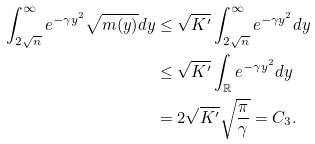<formula> <loc_0><loc_0><loc_500><loc_500>\int _ { 2 \sqrt { n } } ^ { \infty } e ^ { - \gamma y ^ { 2 } } \sqrt { m ( y ) } d y & \leq \sqrt { K ^ { \prime } } \int _ { 2 \sqrt { n } } ^ { \infty } e ^ { - \gamma y ^ { 2 } } d y \\ & \leq \sqrt { K ^ { \prime } } \int _ { \mathbb { R } } e ^ { - \gamma y ^ { 2 } } d y \\ & = 2 \sqrt { K ^ { \prime } } \sqrt { \frac { \pi } { \gamma } } = C _ { 3 } .</formula> 